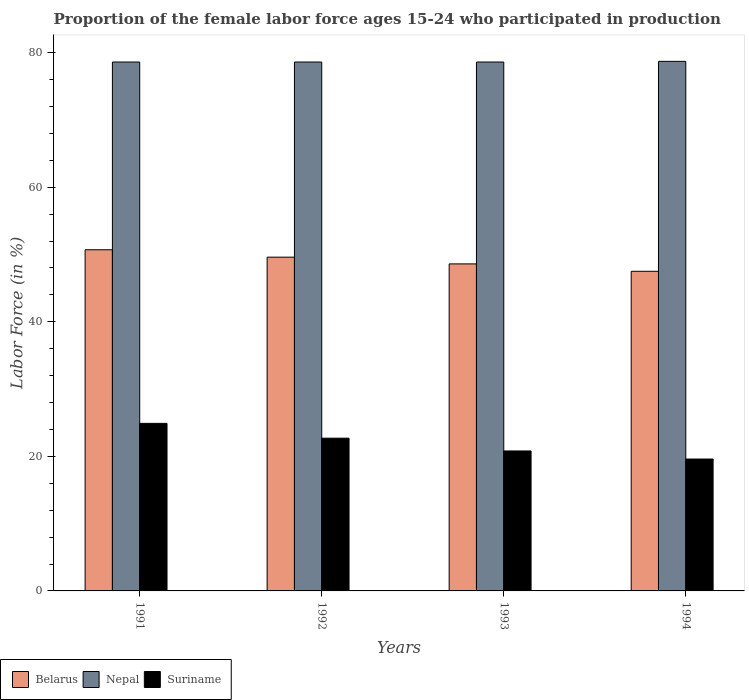How many different coloured bars are there?
Offer a terse response. 3. Are the number of bars on each tick of the X-axis equal?
Offer a very short reply. Yes. How many bars are there on the 4th tick from the left?
Provide a succinct answer. 3. How many bars are there on the 1st tick from the right?
Keep it short and to the point. 3. What is the proportion of the female labor force who participated in production in Suriname in 1991?
Ensure brevity in your answer.  24.9. Across all years, what is the maximum proportion of the female labor force who participated in production in Suriname?
Provide a short and direct response. 24.9. Across all years, what is the minimum proportion of the female labor force who participated in production in Belarus?
Your answer should be compact. 47.5. What is the total proportion of the female labor force who participated in production in Nepal in the graph?
Give a very brief answer. 314.5. What is the difference between the proportion of the female labor force who participated in production in Belarus in 1991 and that in 1994?
Ensure brevity in your answer.  3.2. What is the difference between the proportion of the female labor force who participated in production in Suriname in 1993 and the proportion of the female labor force who participated in production in Belarus in 1991?
Give a very brief answer. -29.9. What is the average proportion of the female labor force who participated in production in Belarus per year?
Provide a short and direct response. 49.1. In the year 1994, what is the difference between the proportion of the female labor force who participated in production in Belarus and proportion of the female labor force who participated in production in Suriname?
Provide a succinct answer. 27.9. What is the ratio of the proportion of the female labor force who participated in production in Belarus in 1991 to that in 1992?
Provide a short and direct response. 1.02. Is the proportion of the female labor force who participated in production in Suriname in 1991 less than that in 1994?
Offer a terse response. No. What is the difference between the highest and the second highest proportion of the female labor force who participated in production in Nepal?
Give a very brief answer. 0.1. What is the difference between the highest and the lowest proportion of the female labor force who participated in production in Nepal?
Your answer should be very brief. 0.1. In how many years, is the proportion of the female labor force who participated in production in Nepal greater than the average proportion of the female labor force who participated in production in Nepal taken over all years?
Your answer should be compact. 1. What does the 3rd bar from the left in 1994 represents?
Your response must be concise. Suriname. What does the 1st bar from the right in 1993 represents?
Provide a succinct answer. Suriname. Is it the case that in every year, the sum of the proportion of the female labor force who participated in production in Nepal and proportion of the female labor force who participated in production in Belarus is greater than the proportion of the female labor force who participated in production in Suriname?
Provide a succinct answer. Yes. How many bars are there?
Make the answer very short. 12. How many years are there in the graph?
Ensure brevity in your answer.  4. What is the difference between two consecutive major ticks on the Y-axis?
Offer a terse response. 20. Are the values on the major ticks of Y-axis written in scientific E-notation?
Your response must be concise. No. How many legend labels are there?
Ensure brevity in your answer.  3. What is the title of the graph?
Provide a succinct answer. Proportion of the female labor force ages 15-24 who participated in production. Does "St. Lucia" appear as one of the legend labels in the graph?
Offer a terse response. No. What is the label or title of the X-axis?
Offer a terse response. Years. What is the Labor Force (in %) of Belarus in 1991?
Your answer should be compact. 50.7. What is the Labor Force (in %) in Nepal in 1991?
Offer a terse response. 78.6. What is the Labor Force (in %) in Suriname in 1991?
Your answer should be very brief. 24.9. What is the Labor Force (in %) in Belarus in 1992?
Provide a succinct answer. 49.6. What is the Labor Force (in %) in Nepal in 1992?
Keep it short and to the point. 78.6. What is the Labor Force (in %) in Suriname in 1992?
Offer a terse response. 22.7. What is the Labor Force (in %) of Belarus in 1993?
Your answer should be very brief. 48.6. What is the Labor Force (in %) of Nepal in 1993?
Offer a terse response. 78.6. What is the Labor Force (in %) of Suriname in 1993?
Ensure brevity in your answer.  20.8. What is the Labor Force (in %) of Belarus in 1994?
Your answer should be compact. 47.5. What is the Labor Force (in %) of Nepal in 1994?
Your response must be concise. 78.7. What is the Labor Force (in %) in Suriname in 1994?
Your answer should be compact. 19.6. Across all years, what is the maximum Labor Force (in %) in Belarus?
Make the answer very short. 50.7. Across all years, what is the maximum Labor Force (in %) in Nepal?
Your response must be concise. 78.7. Across all years, what is the maximum Labor Force (in %) in Suriname?
Provide a short and direct response. 24.9. Across all years, what is the minimum Labor Force (in %) in Belarus?
Offer a terse response. 47.5. Across all years, what is the minimum Labor Force (in %) of Nepal?
Keep it short and to the point. 78.6. Across all years, what is the minimum Labor Force (in %) of Suriname?
Provide a short and direct response. 19.6. What is the total Labor Force (in %) in Belarus in the graph?
Your answer should be compact. 196.4. What is the total Labor Force (in %) of Nepal in the graph?
Your answer should be very brief. 314.5. What is the difference between the Labor Force (in %) of Nepal in 1991 and that in 1992?
Make the answer very short. 0. What is the difference between the Labor Force (in %) of Nepal in 1991 and that in 1993?
Your answer should be compact. 0. What is the difference between the Labor Force (in %) of Belarus in 1991 and that in 1994?
Your answer should be very brief. 3.2. What is the difference between the Labor Force (in %) of Nepal in 1991 and that in 1994?
Provide a succinct answer. -0.1. What is the difference between the Labor Force (in %) of Suriname in 1991 and that in 1994?
Offer a very short reply. 5.3. What is the difference between the Labor Force (in %) of Belarus in 1992 and that in 1993?
Make the answer very short. 1. What is the difference between the Labor Force (in %) in Nepal in 1992 and that in 1993?
Keep it short and to the point. 0. What is the difference between the Labor Force (in %) in Nepal in 1992 and that in 1994?
Ensure brevity in your answer.  -0.1. What is the difference between the Labor Force (in %) in Nepal in 1993 and that in 1994?
Your response must be concise. -0.1. What is the difference between the Labor Force (in %) of Belarus in 1991 and the Labor Force (in %) of Nepal in 1992?
Offer a terse response. -27.9. What is the difference between the Labor Force (in %) in Nepal in 1991 and the Labor Force (in %) in Suriname in 1992?
Ensure brevity in your answer.  55.9. What is the difference between the Labor Force (in %) in Belarus in 1991 and the Labor Force (in %) in Nepal in 1993?
Offer a terse response. -27.9. What is the difference between the Labor Force (in %) in Belarus in 1991 and the Labor Force (in %) in Suriname in 1993?
Your response must be concise. 29.9. What is the difference between the Labor Force (in %) of Nepal in 1991 and the Labor Force (in %) of Suriname in 1993?
Your answer should be very brief. 57.8. What is the difference between the Labor Force (in %) of Belarus in 1991 and the Labor Force (in %) of Suriname in 1994?
Provide a succinct answer. 31.1. What is the difference between the Labor Force (in %) in Belarus in 1992 and the Labor Force (in %) in Suriname in 1993?
Give a very brief answer. 28.8. What is the difference between the Labor Force (in %) of Nepal in 1992 and the Labor Force (in %) of Suriname in 1993?
Your answer should be very brief. 57.8. What is the difference between the Labor Force (in %) of Belarus in 1992 and the Labor Force (in %) of Nepal in 1994?
Your answer should be very brief. -29.1. What is the difference between the Labor Force (in %) of Belarus in 1993 and the Labor Force (in %) of Nepal in 1994?
Keep it short and to the point. -30.1. What is the difference between the Labor Force (in %) in Nepal in 1993 and the Labor Force (in %) in Suriname in 1994?
Offer a very short reply. 59. What is the average Labor Force (in %) of Belarus per year?
Keep it short and to the point. 49.1. What is the average Labor Force (in %) in Nepal per year?
Ensure brevity in your answer.  78.62. What is the average Labor Force (in %) of Suriname per year?
Ensure brevity in your answer.  22. In the year 1991, what is the difference between the Labor Force (in %) in Belarus and Labor Force (in %) in Nepal?
Your response must be concise. -27.9. In the year 1991, what is the difference between the Labor Force (in %) in Belarus and Labor Force (in %) in Suriname?
Make the answer very short. 25.8. In the year 1991, what is the difference between the Labor Force (in %) of Nepal and Labor Force (in %) of Suriname?
Your response must be concise. 53.7. In the year 1992, what is the difference between the Labor Force (in %) of Belarus and Labor Force (in %) of Nepal?
Ensure brevity in your answer.  -29. In the year 1992, what is the difference between the Labor Force (in %) in Belarus and Labor Force (in %) in Suriname?
Your answer should be very brief. 26.9. In the year 1992, what is the difference between the Labor Force (in %) in Nepal and Labor Force (in %) in Suriname?
Your answer should be very brief. 55.9. In the year 1993, what is the difference between the Labor Force (in %) in Belarus and Labor Force (in %) in Suriname?
Provide a short and direct response. 27.8. In the year 1993, what is the difference between the Labor Force (in %) of Nepal and Labor Force (in %) of Suriname?
Make the answer very short. 57.8. In the year 1994, what is the difference between the Labor Force (in %) in Belarus and Labor Force (in %) in Nepal?
Offer a terse response. -31.2. In the year 1994, what is the difference between the Labor Force (in %) in Belarus and Labor Force (in %) in Suriname?
Provide a short and direct response. 27.9. In the year 1994, what is the difference between the Labor Force (in %) in Nepal and Labor Force (in %) in Suriname?
Your answer should be compact. 59.1. What is the ratio of the Labor Force (in %) of Belarus in 1991 to that in 1992?
Offer a very short reply. 1.02. What is the ratio of the Labor Force (in %) in Nepal in 1991 to that in 1992?
Give a very brief answer. 1. What is the ratio of the Labor Force (in %) of Suriname in 1991 to that in 1992?
Offer a terse response. 1.1. What is the ratio of the Labor Force (in %) in Belarus in 1991 to that in 1993?
Keep it short and to the point. 1.04. What is the ratio of the Labor Force (in %) of Nepal in 1991 to that in 1993?
Provide a succinct answer. 1. What is the ratio of the Labor Force (in %) of Suriname in 1991 to that in 1993?
Your response must be concise. 1.2. What is the ratio of the Labor Force (in %) in Belarus in 1991 to that in 1994?
Provide a short and direct response. 1.07. What is the ratio of the Labor Force (in %) of Suriname in 1991 to that in 1994?
Ensure brevity in your answer.  1.27. What is the ratio of the Labor Force (in %) in Belarus in 1992 to that in 1993?
Keep it short and to the point. 1.02. What is the ratio of the Labor Force (in %) of Nepal in 1992 to that in 1993?
Your answer should be compact. 1. What is the ratio of the Labor Force (in %) in Suriname in 1992 to that in 1993?
Give a very brief answer. 1.09. What is the ratio of the Labor Force (in %) of Belarus in 1992 to that in 1994?
Make the answer very short. 1.04. What is the ratio of the Labor Force (in %) of Suriname in 1992 to that in 1994?
Offer a very short reply. 1.16. What is the ratio of the Labor Force (in %) in Belarus in 1993 to that in 1994?
Offer a very short reply. 1.02. What is the ratio of the Labor Force (in %) in Suriname in 1993 to that in 1994?
Ensure brevity in your answer.  1.06. What is the difference between the highest and the second highest Labor Force (in %) in Suriname?
Your response must be concise. 2.2. What is the difference between the highest and the lowest Labor Force (in %) in Belarus?
Make the answer very short. 3.2. What is the difference between the highest and the lowest Labor Force (in %) of Nepal?
Offer a terse response. 0.1. 